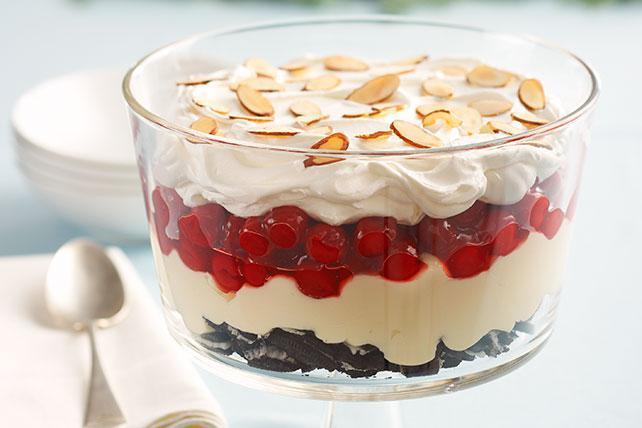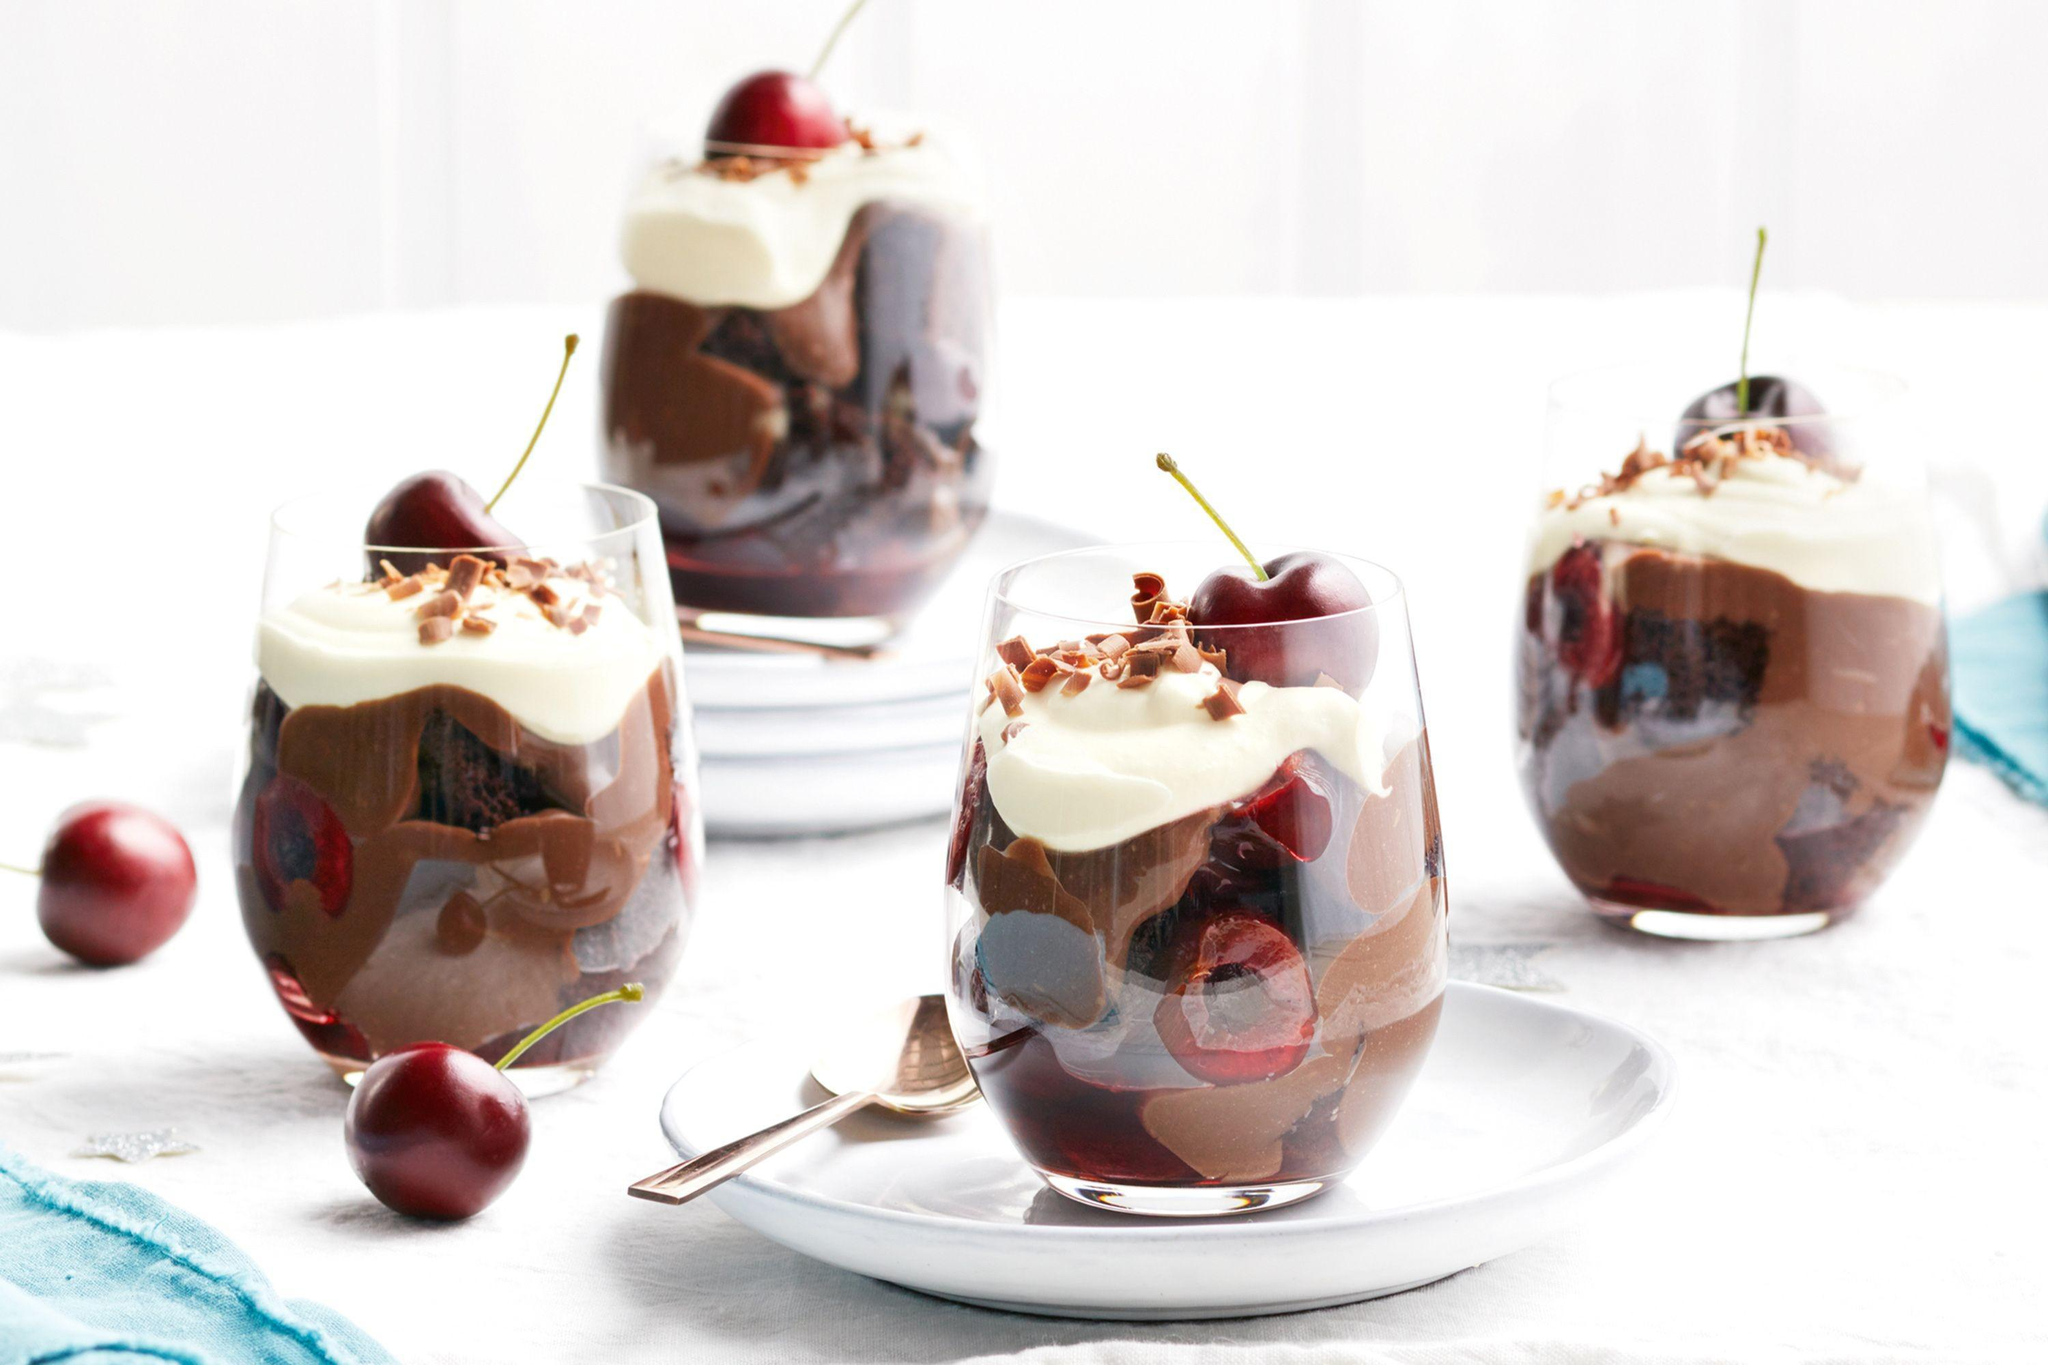The first image is the image on the left, the second image is the image on the right. For the images shown, is this caption "there are two trifles in the image pair" true? Answer yes or no. No. The first image is the image on the left, the second image is the image on the right. Analyze the images presented: Is the assertion "In the right image, there are at least three chocolate deserts." valid? Answer yes or no. Yes. 